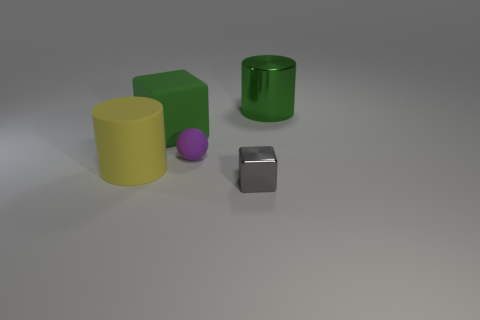Add 1 small purple rubber balls. How many objects exist? 6 Subtract all gray blocks. How many blocks are left? 1 Subtract 1 cylinders. How many cylinders are left? 1 Subtract all yellow spheres. How many yellow cylinders are left? 1 Subtract all big blocks. Subtract all green cylinders. How many objects are left? 3 Add 5 tiny purple spheres. How many tiny purple spheres are left? 6 Add 2 small cubes. How many small cubes exist? 3 Subtract 0 gray cylinders. How many objects are left? 5 Subtract all cylinders. How many objects are left? 3 Subtract all cyan cubes. Subtract all yellow spheres. How many cubes are left? 2 